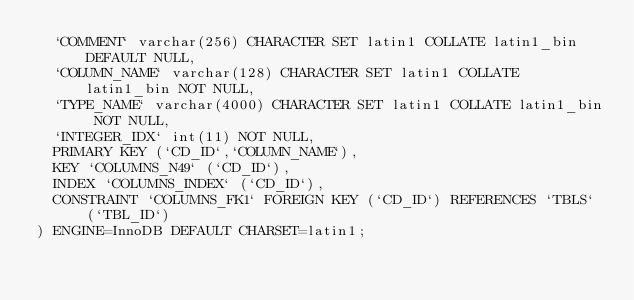<code> <loc_0><loc_0><loc_500><loc_500><_SQL_>  `COMMENT` varchar(256) CHARACTER SET latin1 COLLATE latin1_bin DEFAULT NULL,
  `COLUMN_NAME` varchar(128) CHARACTER SET latin1 COLLATE latin1_bin NOT NULL,
  `TYPE_NAME` varchar(4000) CHARACTER SET latin1 COLLATE latin1_bin NOT NULL,
  `INTEGER_IDX` int(11) NOT NULL,
  PRIMARY KEY (`CD_ID`,`COLUMN_NAME`),
  KEY `COLUMNS_N49` (`CD_ID`),
  INDEX `COLUMNS_INDEX` (`CD_ID`),
  CONSTRAINT `COLUMNS_FK1` FOREIGN KEY (`CD_ID`) REFERENCES `TBLS` (`TBL_ID`)
) ENGINE=InnoDB DEFAULT CHARSET=latin1;
</code> 